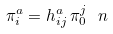<formula> <loc_0><loc_0><loc_500><loc_500>\pi _ { i } ^ { a } = h ^ { a } _ { i j } \, \pi _ { 0 } ^ { j } \ n</formula> 